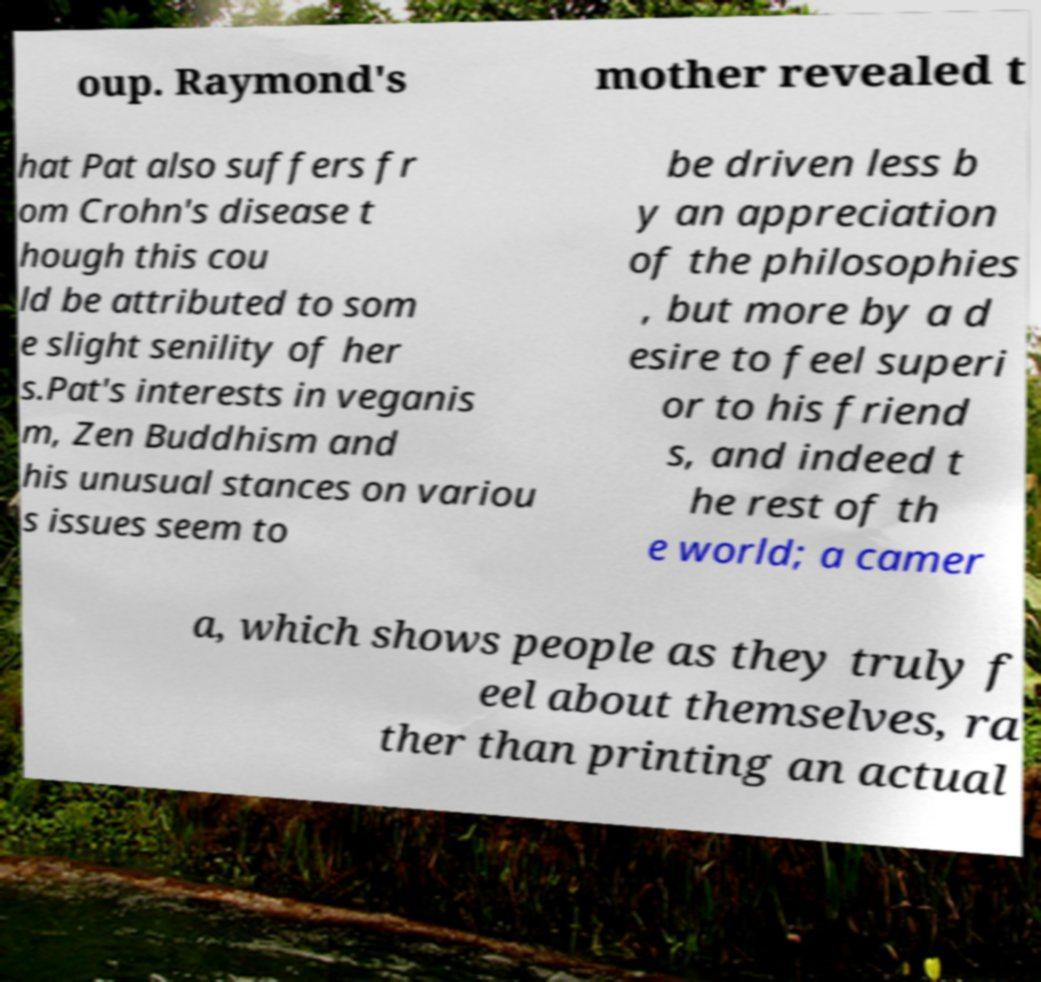I need the written content from this picture converted into text. Can you do that? oup. Raymond's mother revealed t hat Pat also suffers fr om Crohn's disease t hough this cou ld be attributed to som e slight senility of her s.Pat's interests in veganis m, Zen Buddhism and his unusual stances on variou s issues seem to be driven less b y an appreciation of the philosophies , but more by a d esire to feel superi or to his friend s, and indeed t he rest of th e world; a camer a, which shows people as they truly f eel about themselves, ra ther than printing an actual 